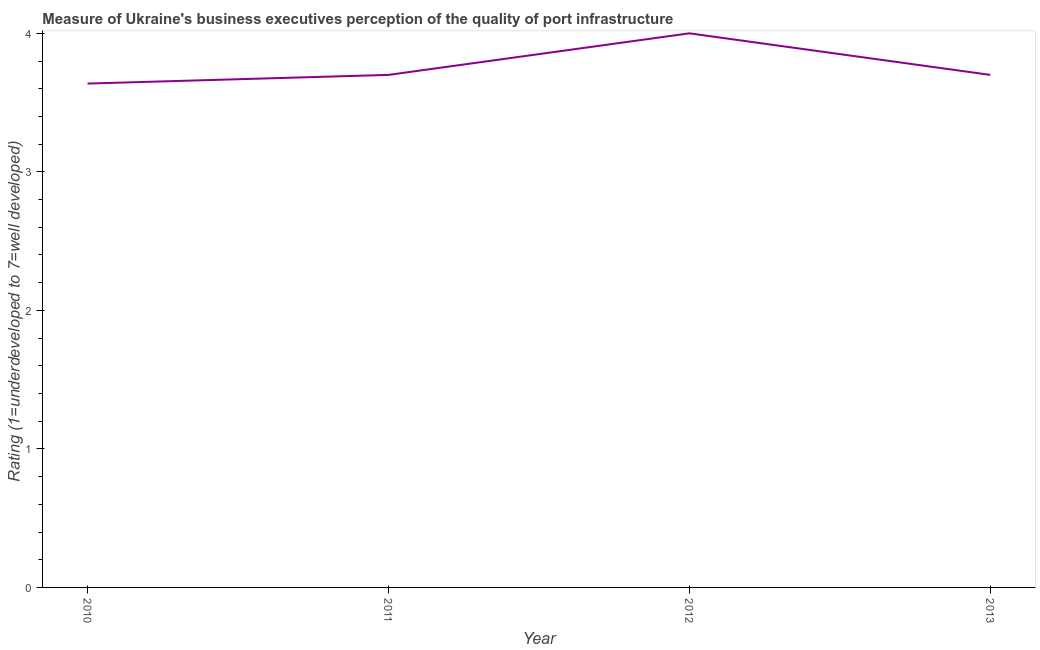Across all years, what is the maximum rating measuring quality of port infrastructure?
Make the answer very short. 4. Across all years, what is the minimum rating measuring quality of port infrastructure?
Provide a short and direct response. 3.64. What is the sum of the rating measuring quality of port infrastructure?
Provide a short and direct response. 15.04. What is the difference between the rating measuring quality of port infrastructure in 2010 and 2011?
Your answer should be very brief. -0.06. What is the average rating measuring quality of port infrastructure per year?
Ensure brevity in your answer.  3.76. Do a majority of the years between 2010 and 2011 (inclusive) have rating measuring quality of port infrastructure greater than 1.4 ?
Your response must be concise. Yes. What is the ratio of the rating measuring quality of port infrastructure in 2010 to that in 2013?
Your answer should be compact. 0.98. Is the rating measuring quality of port infrastructure in 2011 less than that in 2013?
Make the answer very short. No. Is the difference between the rating measuring quality of port infrastructure in 2010 and 2012 greater than the difference between any two years?
Your answer should be compact. Yes. What is the difference between the highest and the second highest rating measuring quality of port infrastructure?
Give a very brief answer. 0.3. Is the sum of the rating measuring quality of port infrastructure in 2010 and 2013 greater than the maximum rating measuring quality of port infrastructure across all years?
Ensure brevity in your answer.  Yes. What is the difference between the highest and the lowest rating measuring quality of port infrastructure?
Your answer should be compact. 0.36. Does the rating measuring quality of port infrastructure monotonically increase over the years?
Ensure brevity in your answer.  No. How many years are there in the graph?
Your answer should be compact. 4. What is the difference between two consecutive major ticks on the Y-axis?
Offer a very short reply. 1. Are the values on the major ticks of Y-axis written in scientific E-notation?
Offer a very short reply. No. Does the graph contain any zero values?
Your response must be concise. No. Does the graph contain grids?
Make the answer very short. No. What is the title of the graph?
Your response must be concise. Measure of Ukraine's business executives perception of the quality of port infrastructure. What is the label or title of the X-axis?
Offer a very short reply. Year. What is the label or title of the Y-axis?
Give a very brief answer. Rating (1=underdeveloped to 7=well developed) . What is the Rating (1=underdeveloped to 7=well developed)  of 2010?
Your answer should be compact. 3.64. What is the Rating (1=underdeveloped to 7=well developed)  in 2011?
Your answer should be compact. 3.7. What is the Rating (1=underdeveloped to 7=well developed)  in 2012?
Provide a short and direct response. 4. What is the Rating (1=underdeveloped to 7=well developed)  of 2013?
Your response must be concise. 3.7. What is the difference between the Rating (1=underdeveloped to 7=well developed)  in 2010 and 2011?
Ensure brevity in your answer.  -0.06. What is the difference between the Rating (1=underdeveloped to 7=well developed)  in 2010 and 2012?
Provide a short and direct response. -0.36. What is the difference between the Rating (1=underdeveloped to 7=well developed)  in 2010 and 2013?
Provide a succinct answer. -0.06. What is the ratio of the Rating (1=underdeveloped to 7=well developed)  in 2010 to that in 2012?
Offer a very short reply. 0.91. What is the ratio of the Rating (1=underdeveloped to 7=well developed)  in 2010 to that in 2013?
Your answer should be very brief. 0.98. What is the ratio of the Rating (1=underdeveloped to 7=well developed)  in 2011 to that in 2012?
Your answer should be very brief. 0.93. What is the ratio of the Rating (1=underdeveloped to 7=well developed)  in 2012 to that in 2013?
Give a very brief answer. 1.08. 